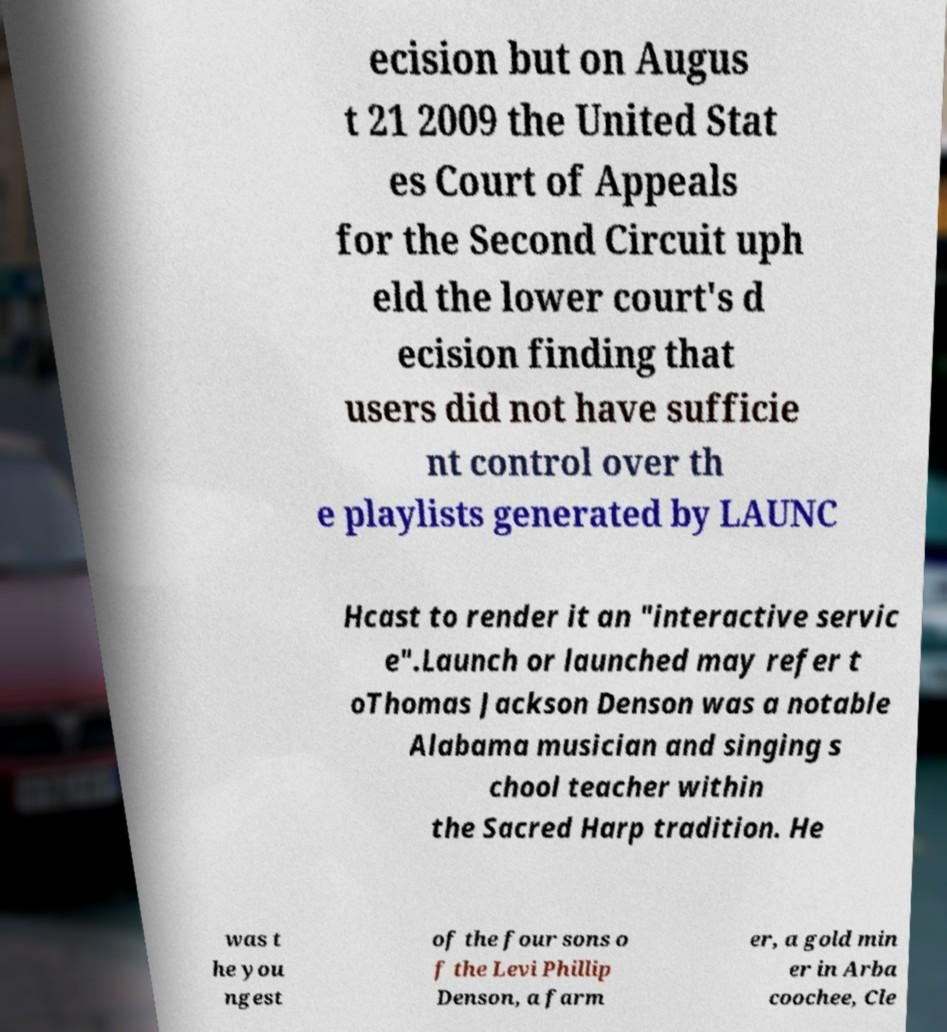Can you accurately transcribe the text from the provided image for me? ecision but on Augus t 21 2009 the United Stat es Court of Appeals for the Second Circuit uph eld the lower court's d ecision finding that users did not have sufficie nt control over th e playlists generated by LAUNC Hcast to render it an "interactive servic e".Launch or launched may refer t oThomas Jackson Denson was a notable Alabama musician and singing s chool teacher within the Sacred Harp tradition. He was t he you ngest of the four sons o f the Levi Phillip Denson, a farm er, a gold min er in Arba coochee, Cle 